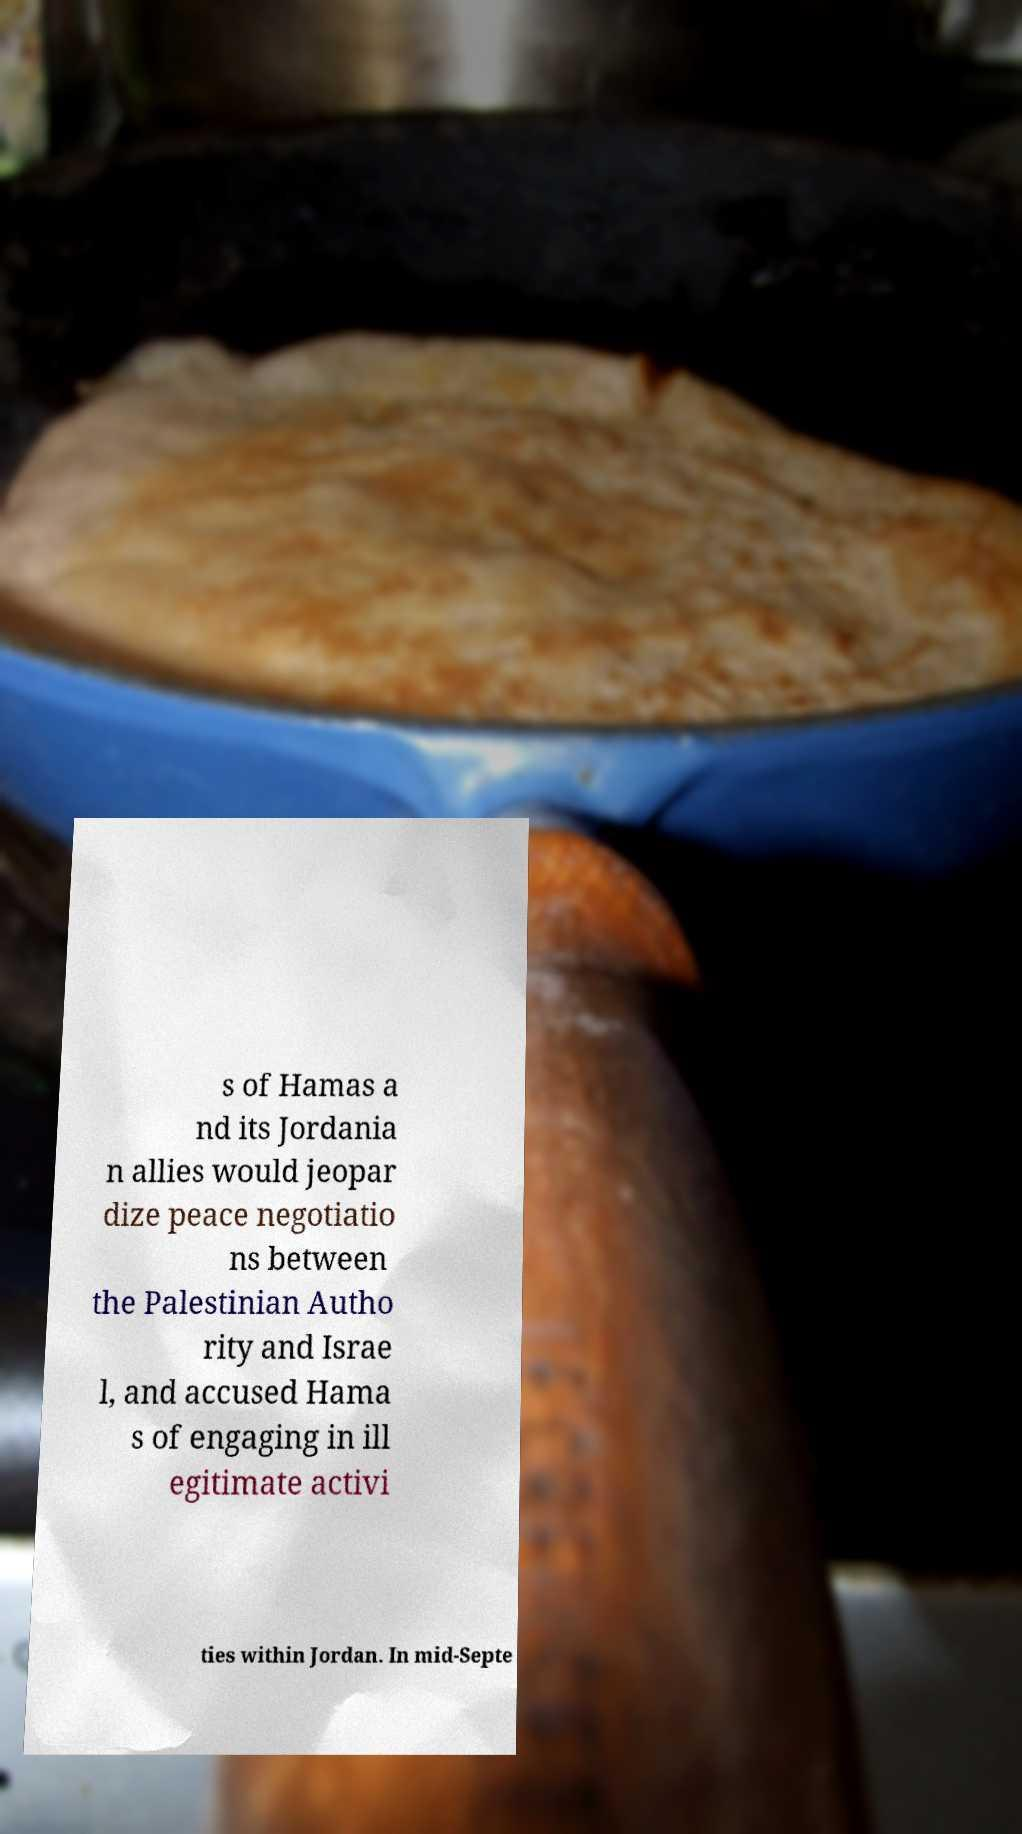Please identify and transcribe the text found in this image. s of Hamas a nd its Jordania n allies would jeopar dize peace negotiatio ns between the Palestinian Autho rity and Israe l, and accused Hama s of engaging in ill egitimate activi ties within Jordan. In mid-Septe 